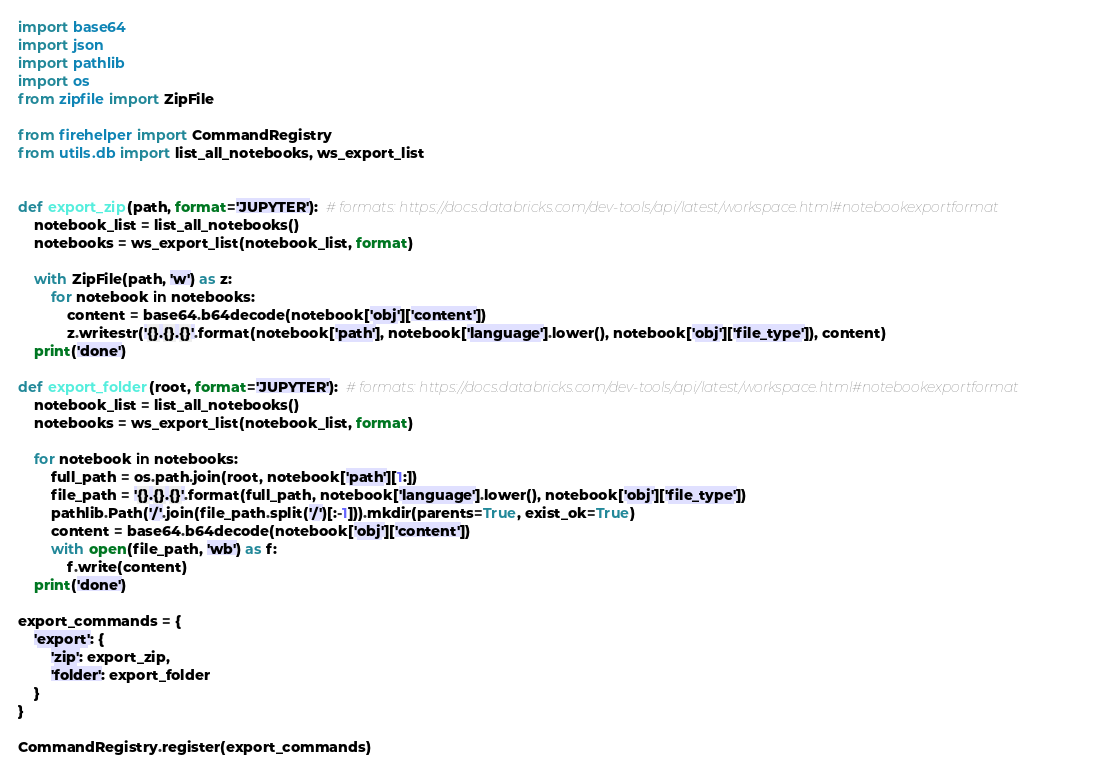<code> <loc_0><loc_0><loc_500><loc_500><_Python_>import base64
import json
import pathlib
import os
from zipfile import ZipFile

from firehelper import CommandRegistry
from utils.db import list_all_notebooks, ws_export_list


def export_zip(path, format='JUPYTER'):  # formats: https://docs.databricks.com/dev-tools/api/latest/workspace.html#notebookexportformat
    notebook_list = list_all_notebooks()
    notebooks = ws_export_list(notebook_list, format)

    with ZipFile(path, 'w') as z:
        for notebook in notebooks:
            content = base64.b64decode(notebook['obj']['content'])
            z.writestr('{}.{}.{}'.format(notebook['path'], notebook['language'].lower(), notebook['obj']['file_type']), content)
    print('done')
    
def export_folder(root, format='JUPYTER'):  # formats: https://docs.databricks.com/dev-tools/api/latest/workspace.html#notebookexportformat
    notebook_list = list_all_notebooks()
    notebooks = ws_export_list(notebook_list, format)

    for notebook in notebooks:
        full_path = os.path.join(root, notebook['path'][1:])
        file_path = '{}.{}.{}'.format(full_path, notebook['language'].lower(), notebook['obj']['file_type'])
        pathlib.Path('/'.join(file_path.split('/')[:-1])).mkdir(parents=True, exist_ok=True)
        content = base64.b64decode(notebook['obj']['content'])
        with open(file_path, 'wb') as f:
            f.write(content)
    print('done')

export_commands = {
    'export': {
        'zip': export_zip,
        'folder': export_folder
    }
}

CommandRegistry.register(export_commands)
</code> 